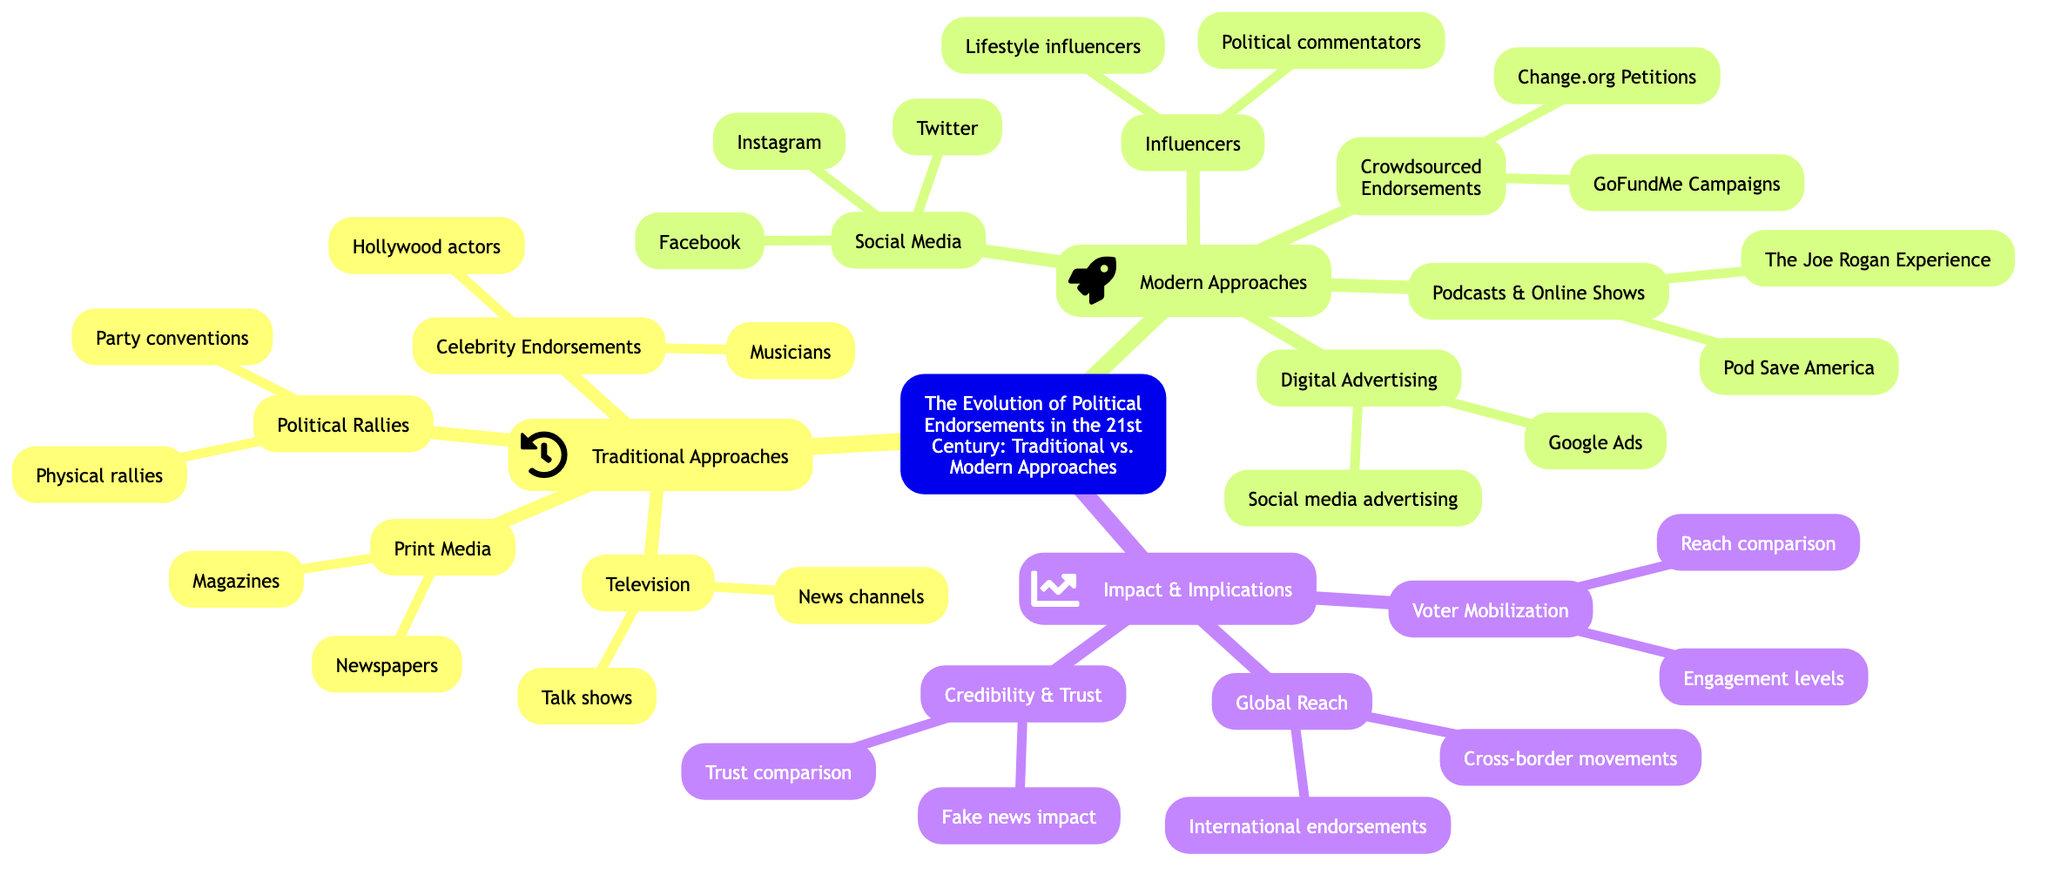What are the two main categories outlined in the diagram? The diagram categorizes approaches into "Traditional Approaches" and "Modern Approaches." This is explicitly stated as the two main branches stemming from the central topic of the mind map.
Answer: Traditional Approaches, Modern Approaches How many subtopics are under "Traditional Approaches"? Under "Traditional Approaches," there are four distinct subtopics: Print Media, Political Rallies, Television, and Celebrity Endorsements. Counting these branches gives the answer.
Answer: 4 What platform is listed under "Social Media"? The diagram specifically mentions Twitter, Facebook, and Instagram as platforms under the "Social Media" subtopic. The question aims at finding one example.
Answer: Twitter Which modern approach involves popular shows or series? The "Podcasts & Online Shows" subtopic provides the examples "Pod Save America" and "The Joe Rogan Experience," indicating that this modern approach includes these programs.
Answer: Podcasts & Online Shows What impact is related to "Credibility & Trust"? The subtopic "Credibility & Trust" outlines considerations such as "Impact of fake news and misinformation" and "Trust in traditional media vs. digital platforms." Both points relate directly to this impact.
Answer: Fake news impact, Trust comparison Which category focuses on "Voter Mobilization"? The subtopic "Voter Mobilization" is found under the "Impact & Implications" branch, indicating that this specific impact is related to understanding how endorsements influence voter engagement.
Answer: Voter Mobilization How many platforms are listed under "Crowdsourced Endorsements"? The subtopic "Crowdsourced Endorsements" mentions two platforms: "Change.org Petitions" and "GoFundMe Campaigns." This can be identified by simply counting the listed items.
Answer: 2 Name an example of a celebrity endorsement mentioned. The diagram mentions several celebrities, such as "George Clooney" and "Scarlett Johansson," under "Celebrity Endorsements." Any of these names could serve as an answer.
Answer: George Clooney What is one type of digital advertising listed? Within the "Digital Advertising" subtopic, examples include "Google Ads" and "Social media advertising." A question about this can result in any one of these examples.
Answer: Google Ads How does the reach of traditional media compare to social media? The diagram notes "Reach of traditional media vs. social media" under the "Voter Mobilization" subtopic, indicating a discussion on the effectiveness of both types of media in reaching voters.
Answer: Reach comparison 